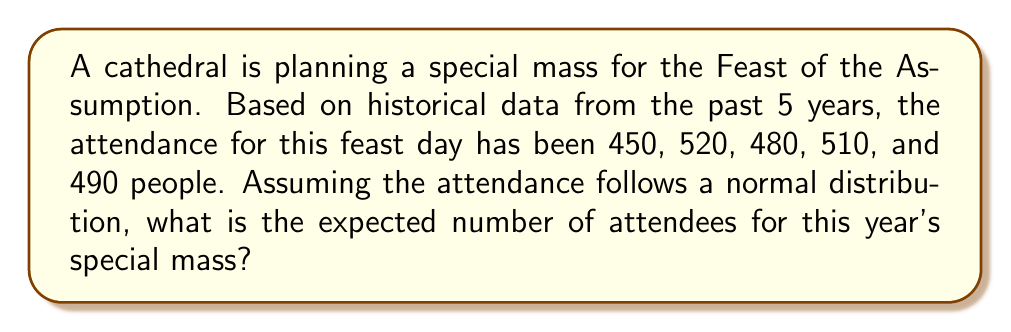Can you answer this question? To determine the expected number of attendees, we need to calculate the mean of the historical data. This mean will serve as our expected value for a normal distribution.

Step 1: List the attendance numbers
$X = \{450, 520, 480, 510, 490\}$

Step 2: Calculate the mean (expected value)
The mean is given by the formula:
$$\mu = E(X) = \frac{1}{n}\sum_{i=1}^n x_i$$

Where $n$ is the number of observations and $x_i$ are the individual values.

$$\mu = \frac{450 + 520 + 480 + 510 + 490}{5}$$

$$\mu = \frac{2450}{5} = 490$$

Therefore, the expected number of attendees for this year's special mass is 490 people.

Note: In a normal distribution, the mean (μ) is equal to the expected value E(X).
Answer: 490 people 